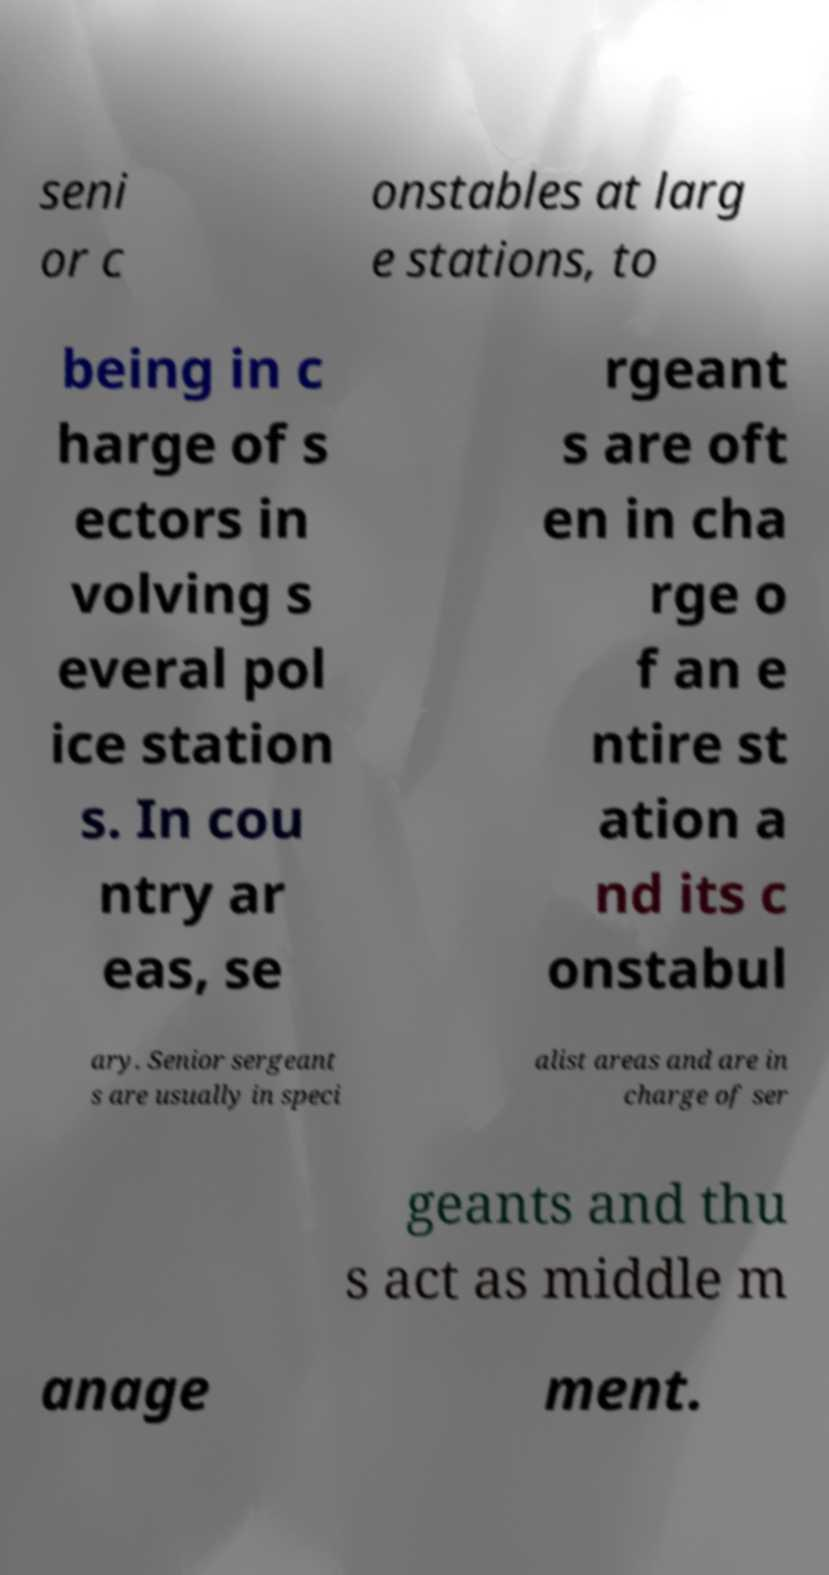Please read and relay the text visible in this image. What does it say? seni or c onstables at larg e stations, to being in c harge of s ectors in volving s everal pol ice station s. In cou ntry ar eas, se rgeant s are oft en in cha rge o f an e ntire st ation a nd its c onstabul ary. Senior sergeant s are usually in speci alist areas and are in charge of ser geants and thu s act as middle m anage ment. 